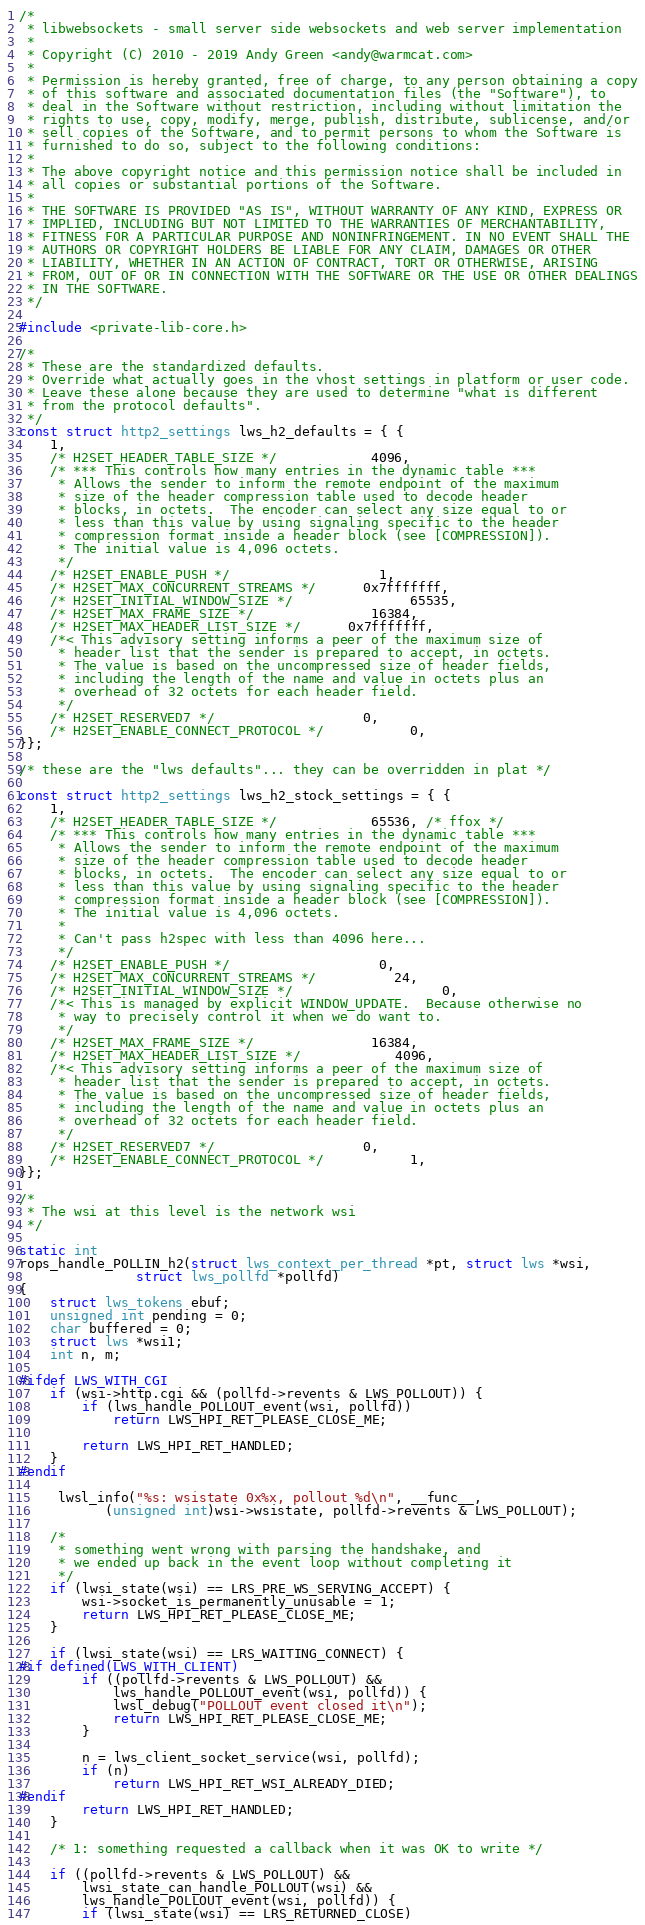<code> <loc_0><loc_0><loc_500><loc_500><_C_>/*
 * libwebsockets - small server side websockets and web server implementation
 *
 * Copyright (C) 2010 - 2019 Andy Green <andy@warmcat.com>
 *
 * Permission is hereby granted, free of charge, to any person obtaining a copy
 * of this software and associated documentation files (the "Software"), to
 * deal in the Software without restriction, including without limitation the
 * rights to use, copy, modify, merge, publish, distribute, sublicense, and/or
 * sell copies of the Software, and to permit persons to whom the Software is
 * furnished to do so, subject to the following conditions:
 *
 * The above copyright notice and this permission notice shall be included in
 * all copies or substantial portions of the Software.
 *
 * THE SOFTWARE IS PROVIDED "AS IS", WITHOUT WARRANTY OF ANY KIND, EXPRESS OR
 * IMPLIED, INCLUDING BUT NOT LIMITED TO THE WARRANTIES OF MERCHANTABILITY,
 * FITNESS FOR A PARTICULAR PURPOSE AND NONINFRINGEMENT. IN NO EVENT SHALL THE
 * AUTHORS OR COPYRIGHT HOLDERS BE LIABLE FOR ANY CLAIM, DAMAGES OR OTHER
 * LIABILITY, WHETHER IN AN ACTION OF CONTRACT, TORT OR OTHERWISE, ARISING
 * FROM, OUT OF OR IN CONNECTION WITH THE SOFTWARE OR THE USE OR OTHER DEALINGS
 * IN THE SOFTWARE.
 */

#include <private-lib-core.h>

/*
 * These are the standardized defaults.
 * Override what actually goes in the vhost settings in platform or user code.
 * Leave these alone because they are used to determine "what is different
 * from the protocol defaults".
 */
const struct http2_settings lws_h2_defaults = { {
	1,
	/* H2SET_HEADER_TABLE_SIZE */			4096,
	/* *** This controls how many entries in the dynamic table ***
	 * Allows the sender to inform the remote endpoint of the maximum
	 * size of the header compression table used to decode header
	 * blocks, in octets.  The encoder can select any size equal to or
	 * less than this value by using signaling specific to the header
	 * compression format inside a header block (see [COMPRESSION]).
	 * The initial value is 4,096 octets.
	 */
	/* H2SET_ENABLE_PUSH */				   1,
	/* H2SET_MAX_CONCURRENT_STREAMS */	  0x7fffffff,
	/* H2SET_INITIAL_WINDOW_SIZE */		       65535,
	/* H2SET_MAX_FRAME_SIZE */		       16384,
	/* H2SET_MAX_HEADER_LIST_SIZE */	  0x7fffffff,
	/*< This advisory setting informs a peer of the maximum size of
	 * header list that the sender is prepared to accept, in octets.
	 * The value is based on the uncompressed size of header fields,
	 * including the length of the name and value in octets plus an
	 * overhead of 32 octets for each header field.
	 */
	/* H2SET_RESERVED7 */				   0,
	/* H2SET_ENABLE_CONNECT_PROTOCOL */		   0,
}};

/* these are the "lws defaults"... they can be overridden in plat */

const struct http2_settings lws_h2_stock_settings = { {
	1,
	/* H2SET_HEADER_TABLE_SIZE */			65536, /* ffox */
	/* *** This controls how many entries in the dynamic table ***
	 * Allows the sender to inform the remote endpoint of the maximum
	 * size of the header compression table used to decode header
	 * blocks, in octets.  The encoder can select any size equal to or
	 * less than this value by using signaling specific to the header
	 * compression format inside a header block (see [COMPRESSION]).
	 * The initial value is 4,096 octets.
	 *
	 * Can't pass h2spec with less than 4096 here...
	 */
	/* H2SET_ENABLE_PUSH */				   0,
	/* H2SET_MAX_CONCURRENT_STREAMS */		  24,
	/* H2SET_INITIAL_WINDOW_SIZE */		           0,
	/*< This is managed by explicit WINDOW_UPDATE.  Because otherwise no
	 * way to precisely control it when we do want to.
	 */
	/* H2SET_MAX_FRAME_SIZE */		       16384,
	/* H2SET_MAX_HEADER_LIST_SIZE */	        4096,
	/*< This advisory setting informs a peer of the maximum size of
	 * header list that the sender is prepared to accept, in octets.
	 * The value is based on the uncompressed size of header fields,
	 * including the length of the name and value in octets plus an
	 * overhead of 32 octets for each header field.
	 */
	/* H2SET_RESERVED7 */				   0,
	/* H2SET_ENABLE_CONNECT_PROTOCOL */		   1,
}};

/*
 * The wsi at this level is the network wsi
 */

static int
rops_handle_POLLIN_h2(struct lws_context_per_thread *pt, struct lws *wsi,
		       struct lws_pollfd *pollfd)
{
	struct lws_tokens ebuf;
	unsigned int pending = 0;
	char buffered = 0;
	struct lws *wsi1;
	int n, m;

#ifdef LWS_WITH_CGI
	if (wsi->http.cgi && (pollfd->revents & LWS_POLLOUT)) {
		if (lws_handle_POLLOUT_event(wsi, pollfd))
			return LWS_HPI_RET_PLEASE_CLOSE_ME;

		return LWS_HPI_RET_HANDLED;
	}
#endif

	 lwsl_info("%s: wsistate 0x%x, pollout %d\n", __func__,
		   (unsigned int)wsi->wsistate, pollfd->revents & LWS_POLLOUT);

	/*
	 * something went wrong with parsing the handshake, and
	 * we ended up back in the event loop without completing it
	 */
	if (lwsi_state(wsi) == LRS_PRE_WS_SERVING_ACCEPT) {
		wsi->socket_is_permanently_unusable = 1;
		return LWS_HPI_RET_PLEASE_CLOSE_ME;
	}

	if (lwsi_state(wsi) == LRS_WAITING_CONNECT) {
#if defined(LWS_WITH_CLIENT)
		if ((pollfd->revents & LWS_POLLOUT) &&
		    lws_handle_POLLOUT_event(wsi, pollfd)) {
			lwsl_debug("POLLOUT event closed it\n");
			return LWS_HPI_RET_PLEASE_CLOSE_ME;
		}

		n = lws_client_socket_service(wsi, pollfd);
		if (n)
			return LWS_HPI_RET_WSI_ALREADY_DIED;
#endif
		return LWS_HPI_RET_HANDLED;
	}

	/* 1: something requested a callback when it was OK to write */

	if ((pollfd->revents & LWS_POLLOUT) &&
	    lwsi_state_can_handle_POLLOUT(wsi) &&
	    lws_handle_POLLOUT_event(wsi, pollfd)) {
		if (lwsi_state(wsi) == LRS_RETURNED_CLOSE)</code> 